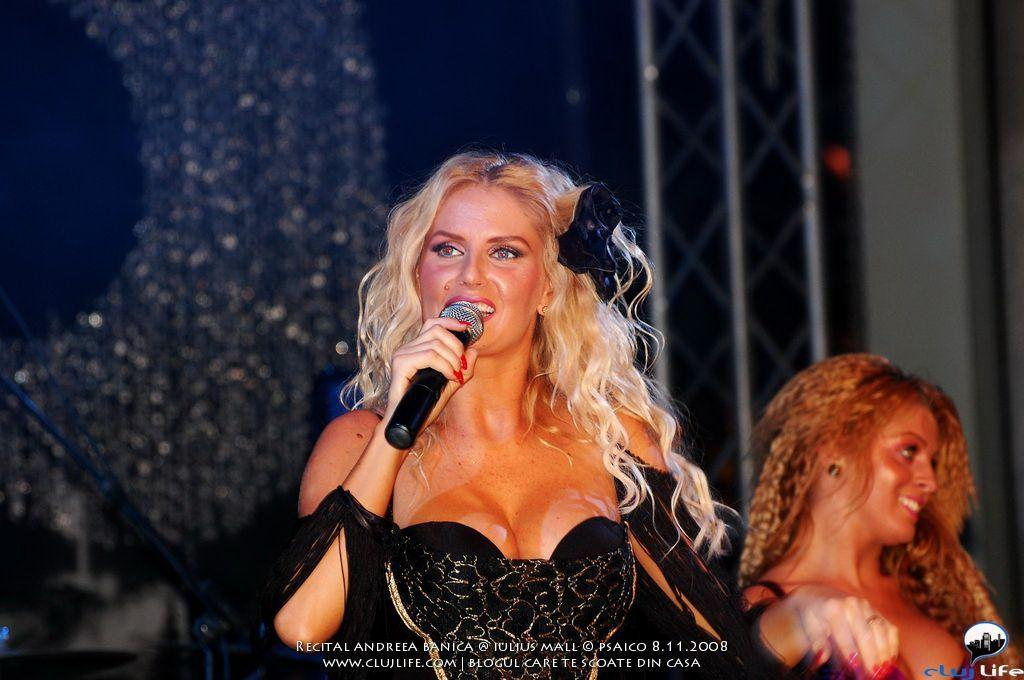How many people are in the image? There are two women in the image. What is one of the women holding? One of the women is holding a mic. What can be seen in the background of the image? There is a metal frame visible in the background. What is present at the bottom of the image? There is some text at the bottom of the image. What type of wire is being used by the woman holding the mic? There is no wire visible in the image; the woman is holding a mic, but the type of wire is not mentioned or shown. 